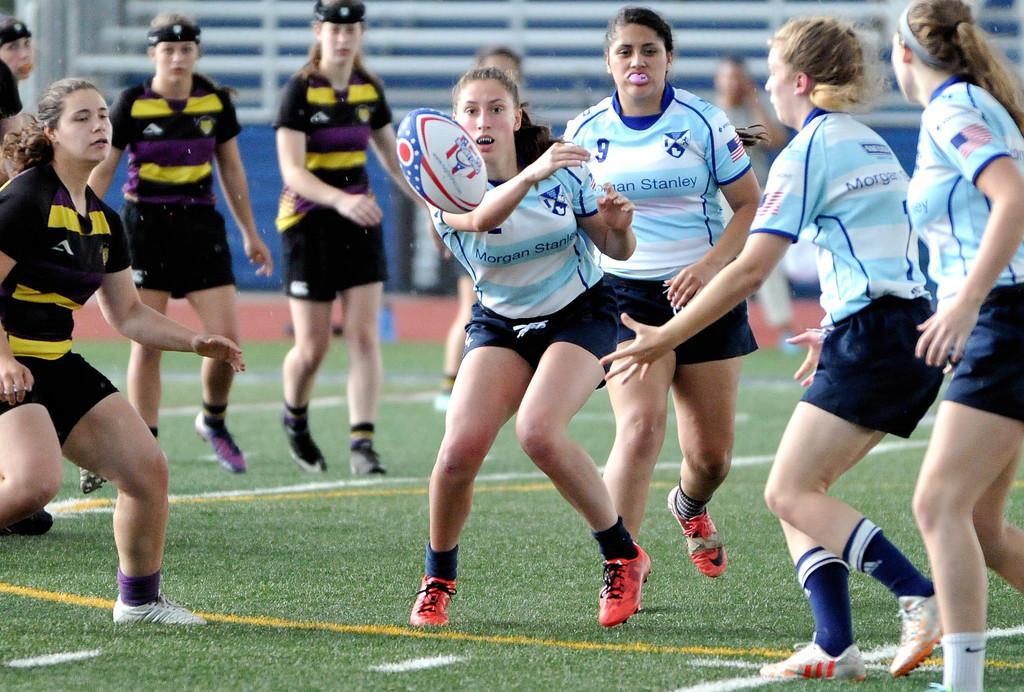Please provide a concise description of this image. In this image I can see there are few girls wearing black color dress and wearing a blue color t-shirt and I can see a ball in the air and they are playing a game in the ground 